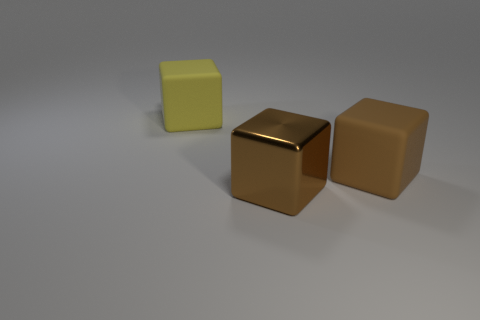Add 1 matte things. How many objects exist? 4 Add 3 large things. How many large things are left? 6 Add 1 big blue matte blocks. How many big blue matte blocks exist? 1 Subtract 0 green balls. How many objects are left? 3 Subtract all yellow matte cubes. Subtract all large matte cubes. How many objects are left? 0 